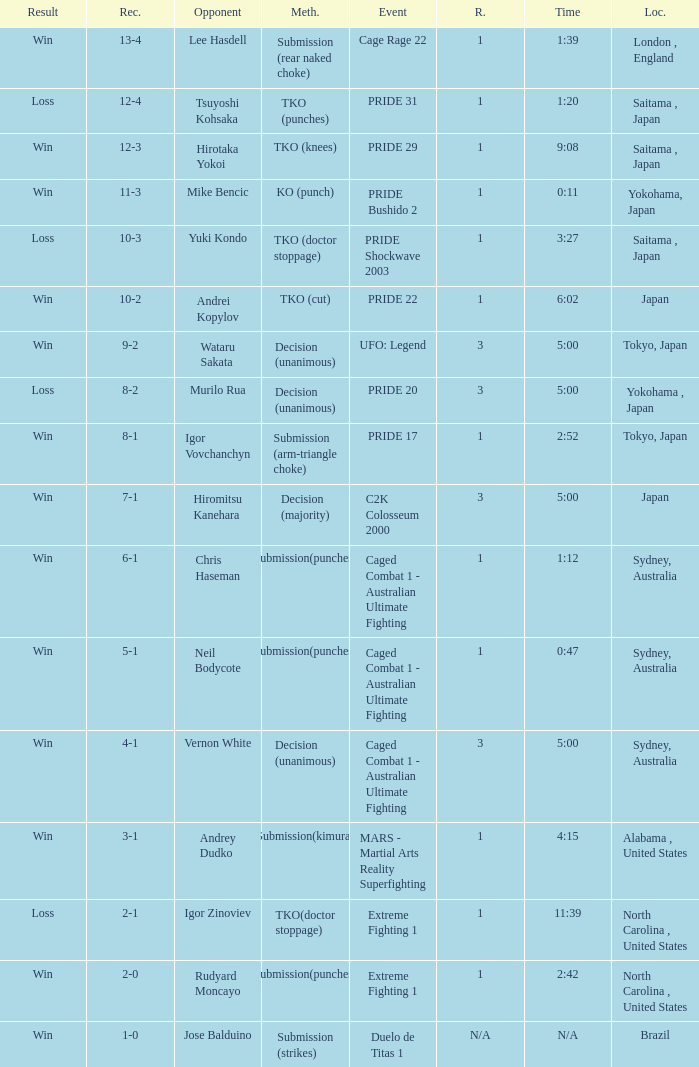Which Record has the Res of win with the Event of extreme fighting 1? 2-0. 